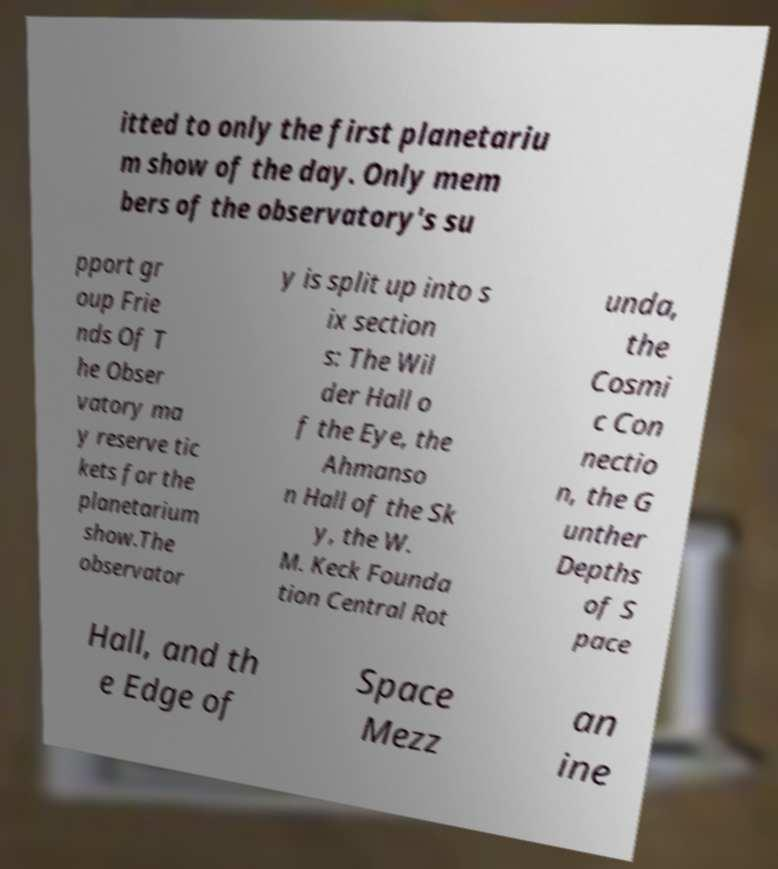For documentation purposes, I need the text within this image transcribed. Could you provide that? itted to only the first planetariu m show of the day. Only mem bers of the observatory's su pport gr oup Frie nds Of T he Obser vatory ma y reserve tic kets for the planetarium show.The observator y is split up into s ix section s: The Wil der Hall o f the Eye, the Ahmanso n Hall of the Sk y, the W. M. Keck Founda tion Central Rot unda, the Cosmi c Con nectio n, the G unther Depths of S pace Hall, and th e Edge of Space Mezz an ine 